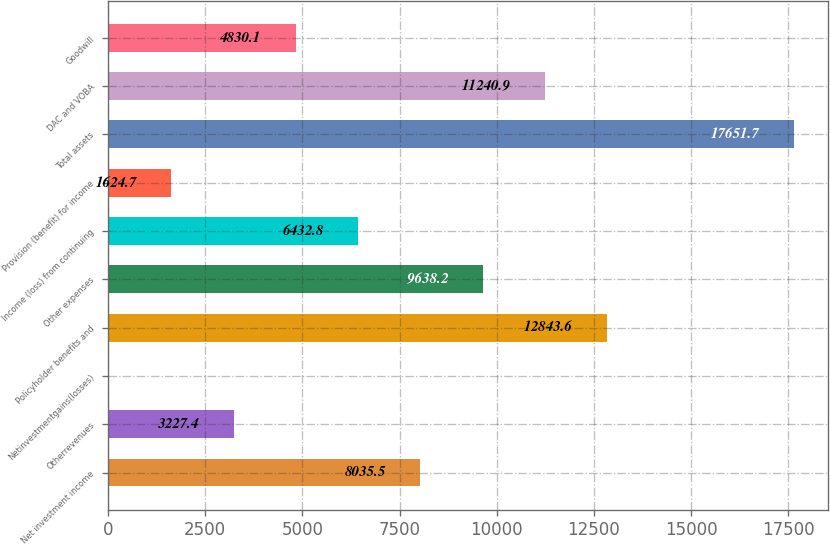<chart> <loc_0><loc_0><loc_500><loc_500><bar_chart><fcel>Net investment income<fcel>Otherrevenues<fcel>Netinvestmentgains(losses)<fcel>Policyholder benefits and<fcel>Other expenses<fcel>Income (loss) from continuing<fcel>Provision (benefit) for income<fcel>Total assets<fcel>DAC and VOBA<fcel>Goodwill<nl><fcel>8035.5<fcel>3227.4<fcel>22<fcel>12843.6<fcel>9638.2<fcel>6432.8<fcel>1624.7<fcel>17651.7<fcel>11240.9<fcel>4830.1<nl></chart> 